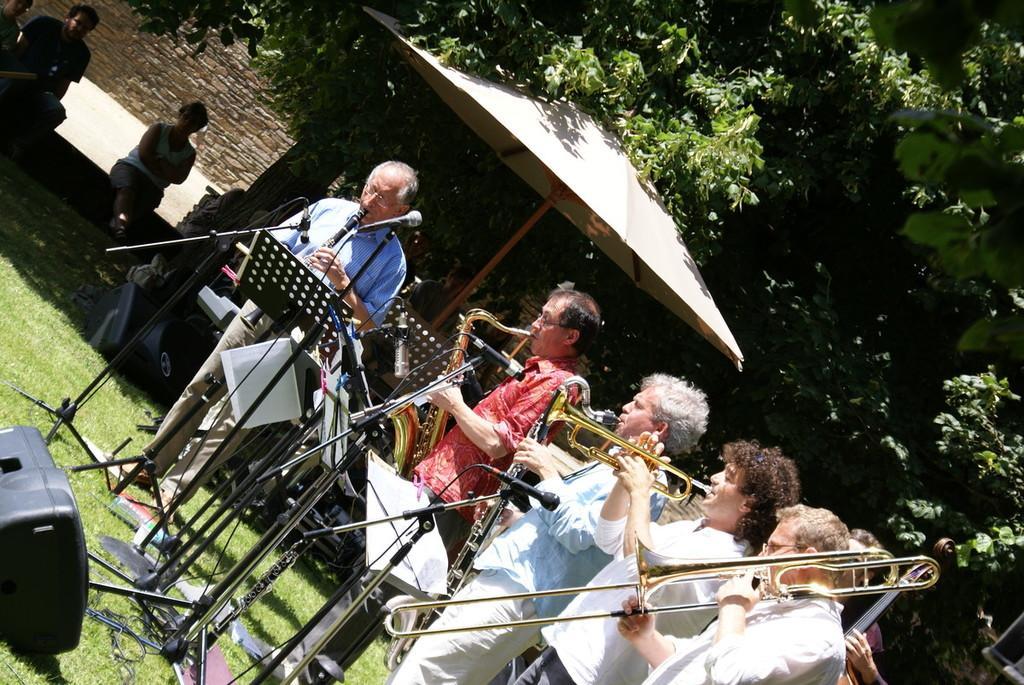In one or two sentences, can you explain what this image depicts? In this image there are group of people standing and holding the musical instruments like a saxophone, a trumpet, a clarinet and a trombone , and there are miles with the miles stands , there are group of people sitting, there is a speaker, there is an umbrella, there are trees. 